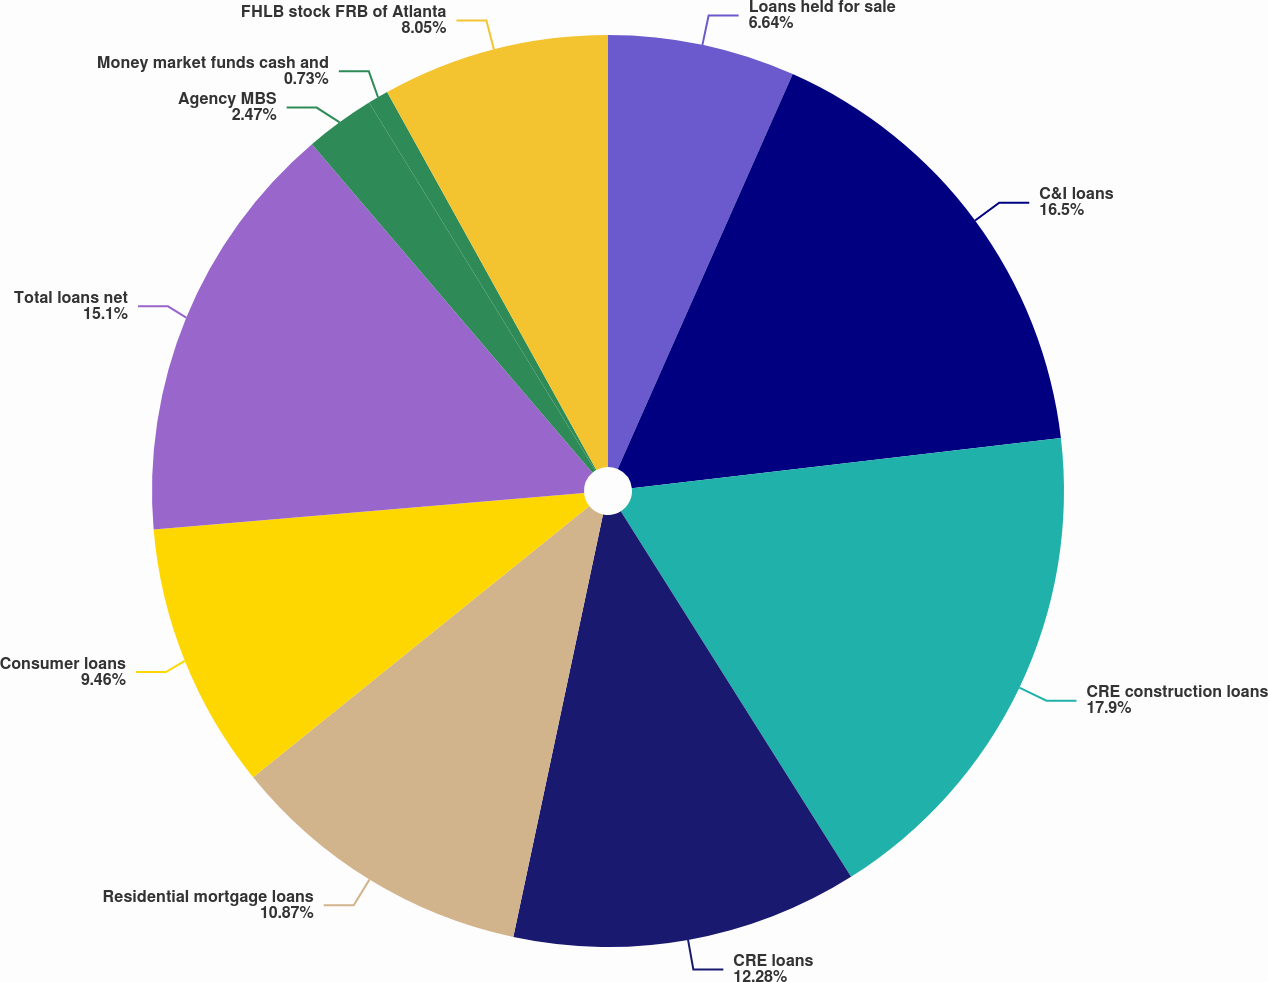Convert chart to OTSL. <chart><loc_0><loc_0><loc_500><loc_500><pie_chart><fcel>Loans held for sale<fcel>C&I loans<fcel>CRE construction loans<fcel>CRE loans<fcel>Residential mortgage loans<fcel>Consumer loans<fcel>Total loans net<fcel>Agency MBS<fcel>Money market funds cash and<fcel>FHLB stock FRB of Atlanta<nl><fcel>6.64%<fcel>16.51%<fcel>17.91%<fcel>12.28%<fcel>10.87%<fcel>9.46%<fcel>15.1%<fcel>2.47%<fcel>0.73%<fcel>8.05%<nl></chart> 